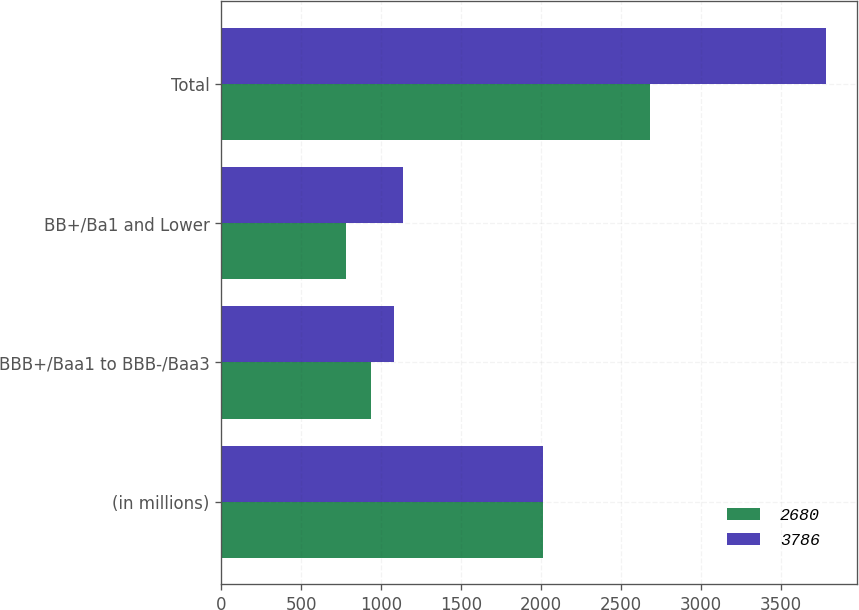Convert chart to OTSL. <chart><loc_0><loc_0><loc_500><loc_500><stacked_bar_chart><ecel><fcel>(in millions)<fcel>BBB+/Baa1 to BBB-/Baa3<fcel>BB+/Ba1 and Lower<fcel>Total<nl><fcel>2680<fcel>2012<fcel>938<fcel>781<fcel>2680<nl><fcel>3786<fcel>2011<fcel>1080<fcel>1136<fcel>3786<nl></chart> 